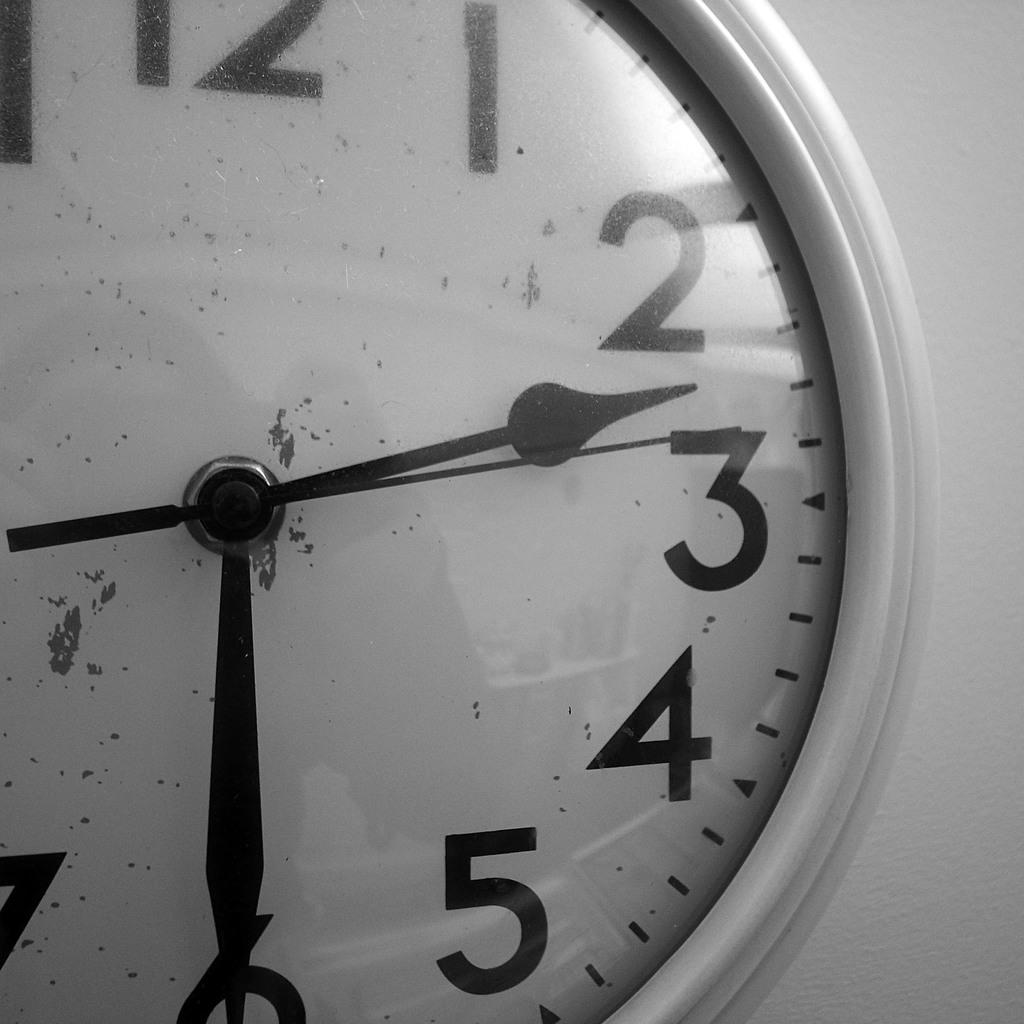<image>
Give a short and clear explanation of the subsequent image. A close up of a white clock shows the time as 2:30. 